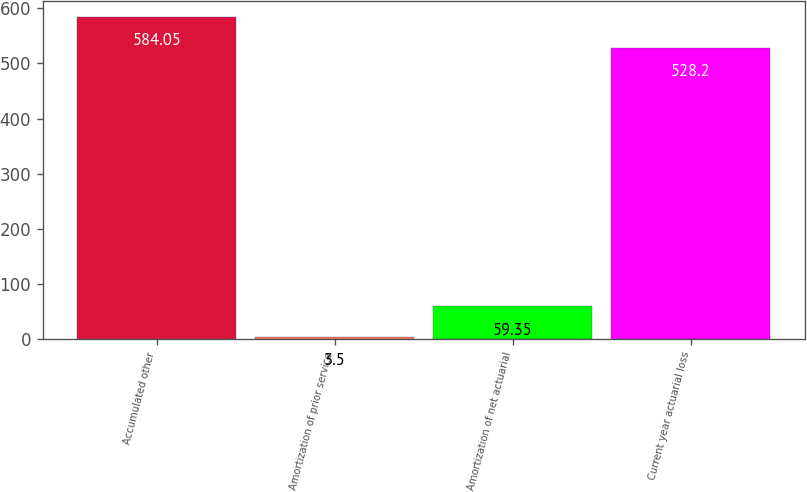<chart> <loc_0><loc_0><loc_500><loc_500><bar_chart><fcel>Accumulated other<fcel>Amortization of prior service<fcel>Amortization of net actuarial<fcel>Current year actuarial loss<nl><fcel>584.05<fcel>3.5<fcel>59.35<fcel>528.2<nl></chart> 